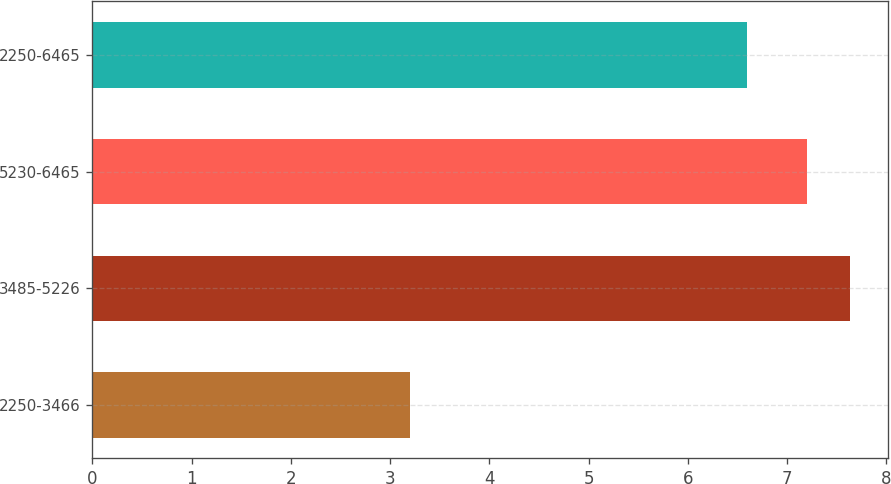Convert chart. <chart><loc_0><loc_0><loc_500><loc_500><bar_chart><fcel>2250-3466<fcel>3485-5226<fcel>5230-6465<fcel>2250-6465<nl><fcel>3.2<fcel>7.63<fcel>7.2<fcel>6.6<nl></chart> 